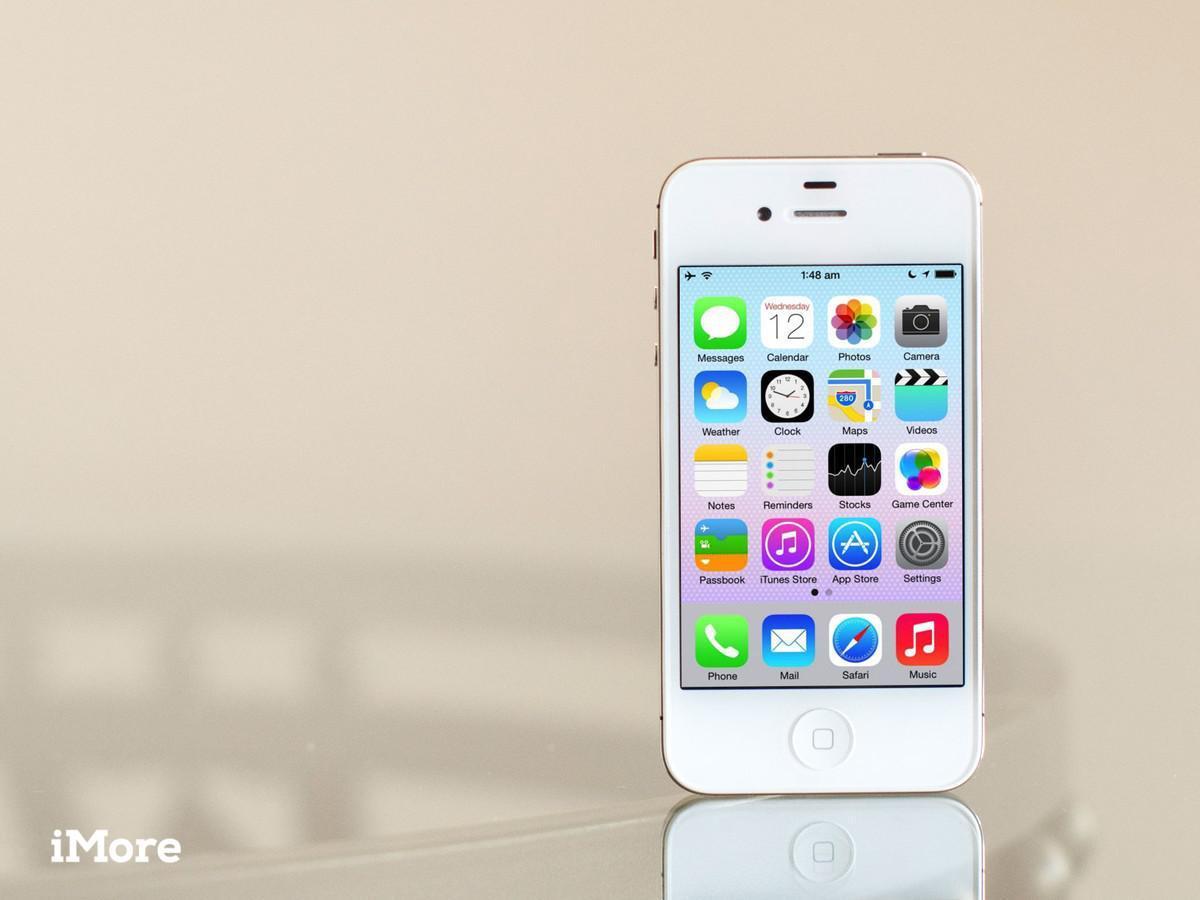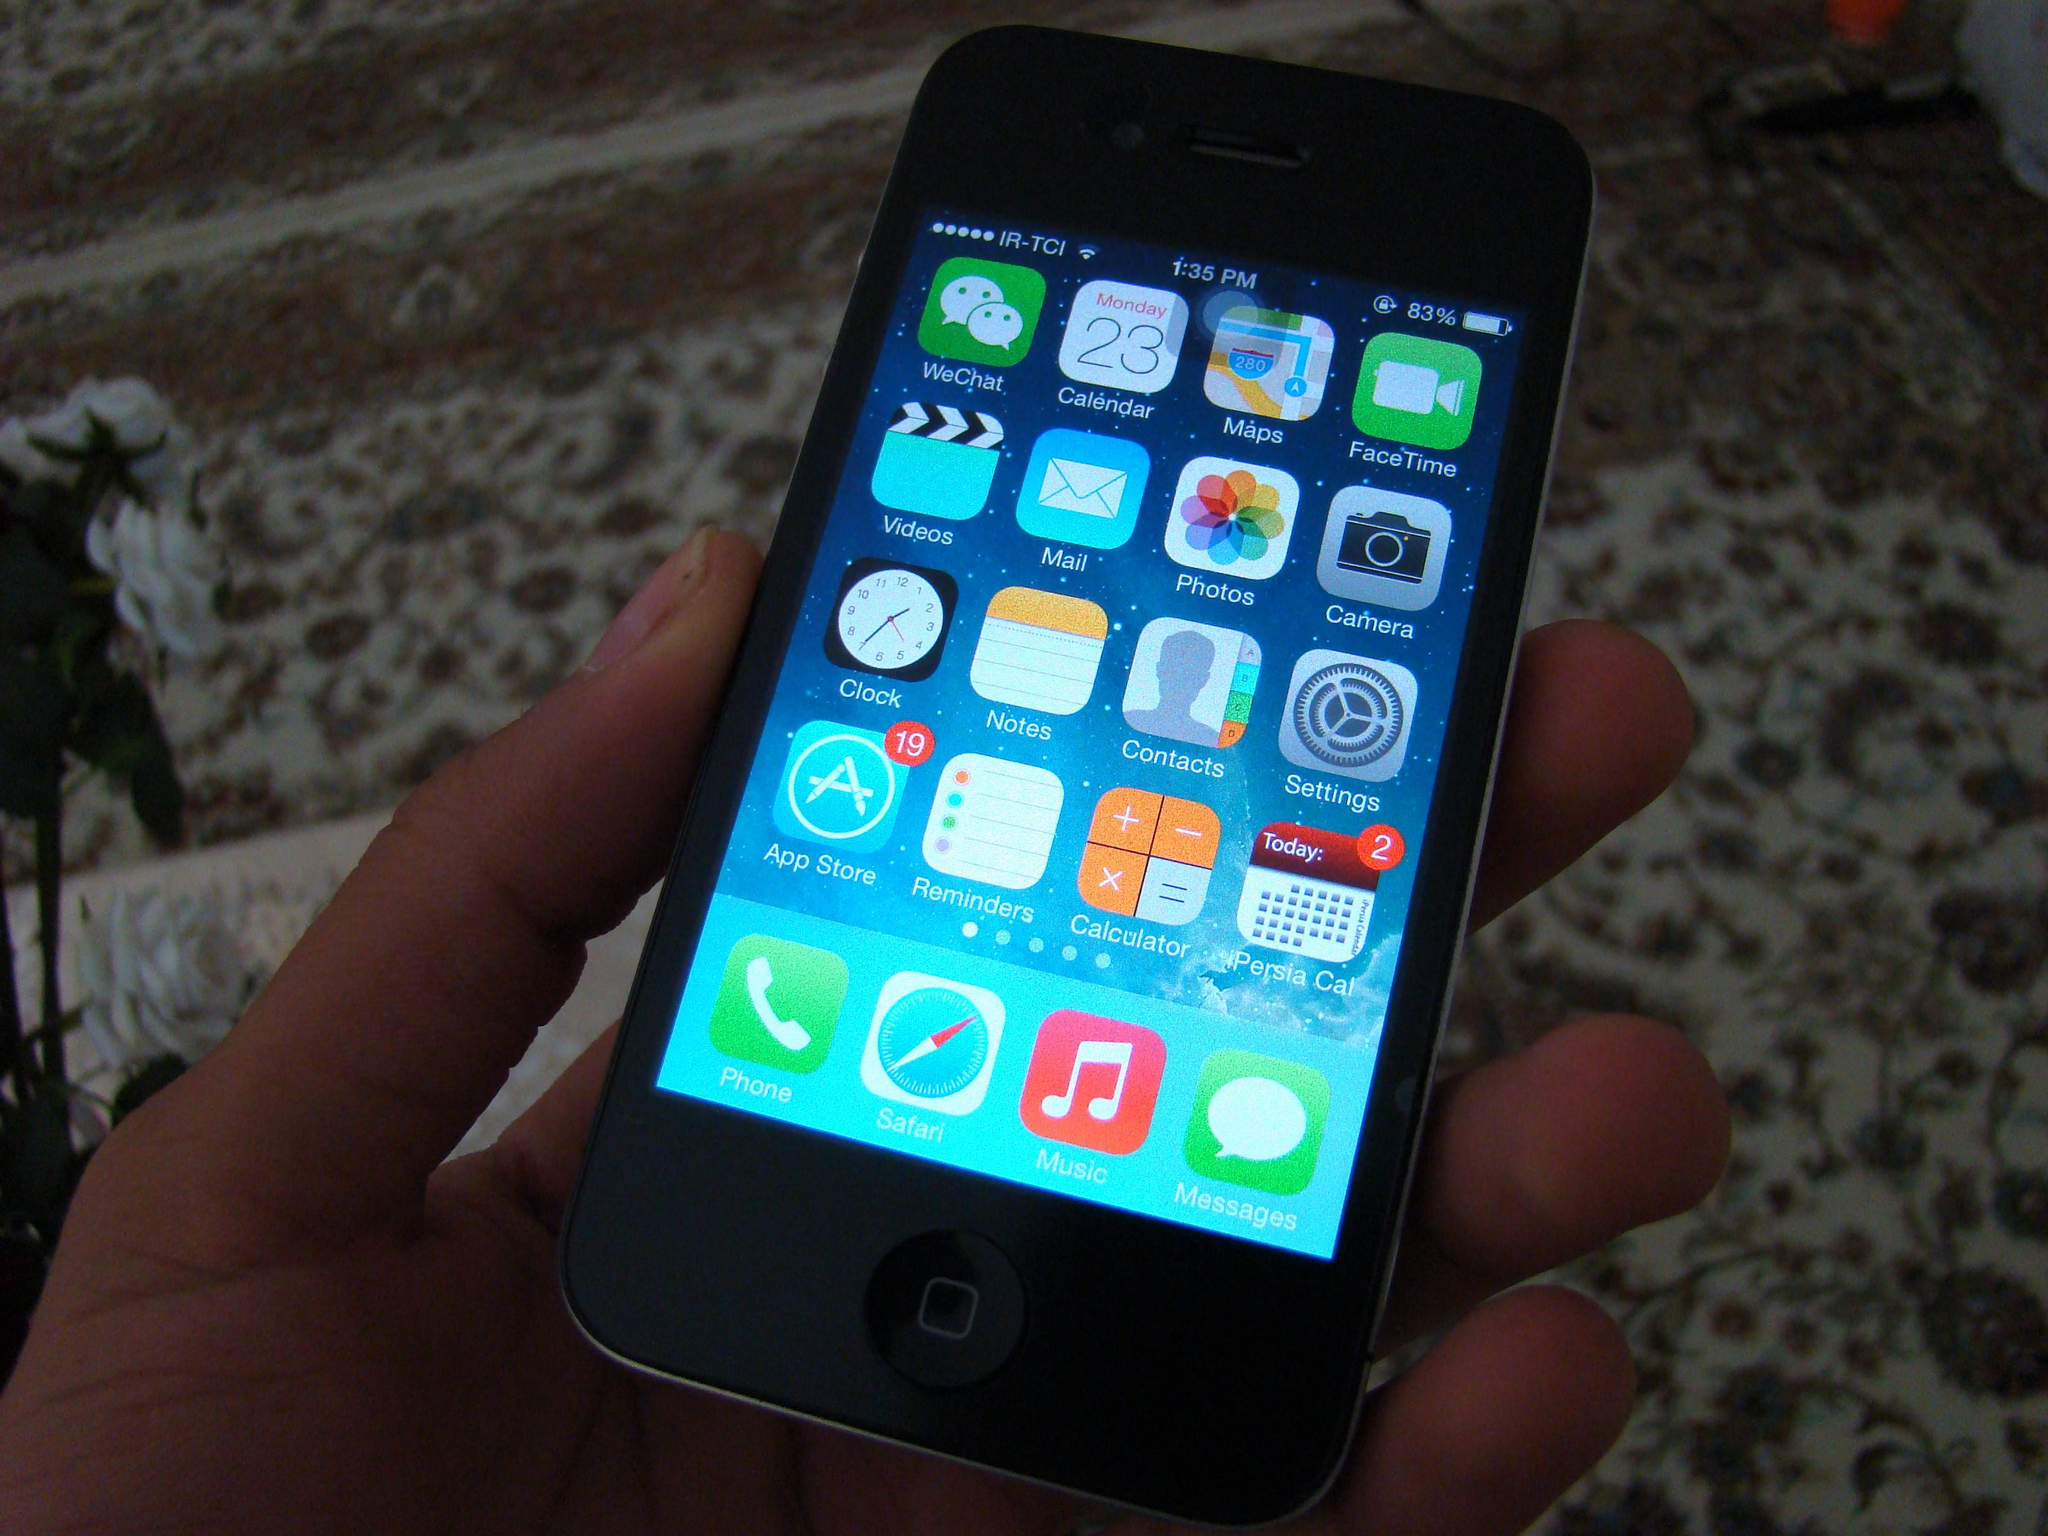The first image is the image on the left, the second image is the image on the right. Considering the images on both sides, is "A phone sits alone in the image on the left, while the phone in the image on the right is held." valid? Answer yes or no. Yes. 